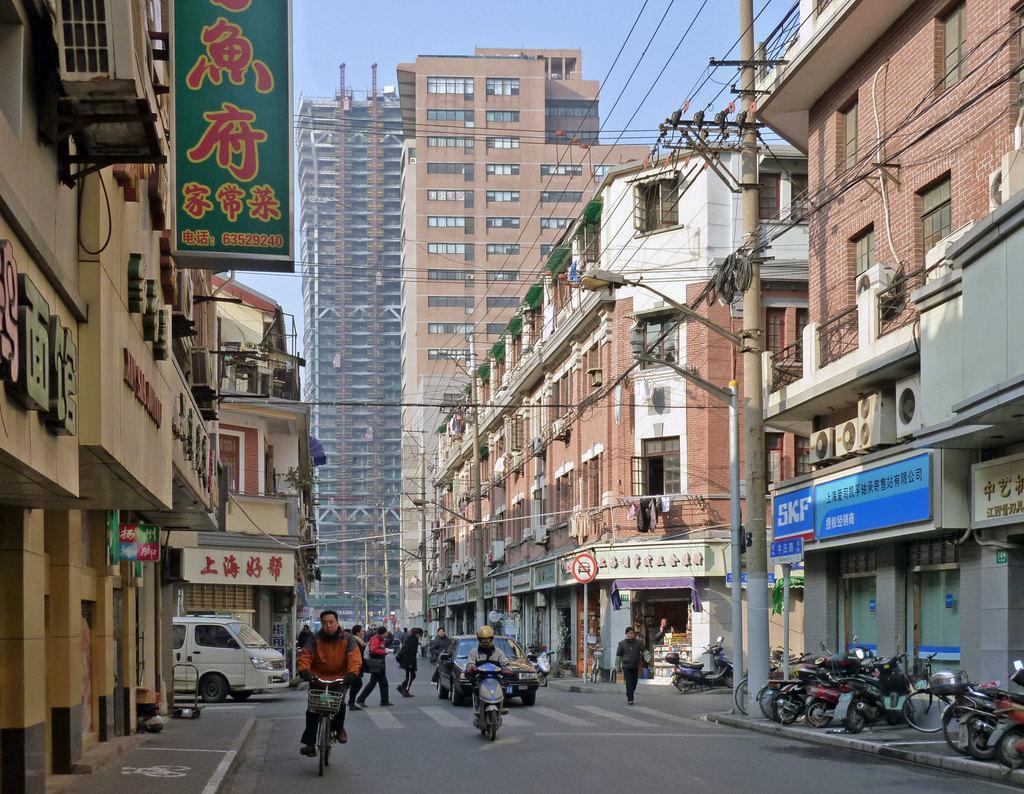Please provide a concise description of this image. Few people walking and these two people riding vehicles. We can see boards, vehicles, road, lights, poles, wires and buildings. In the background we can see sky. 